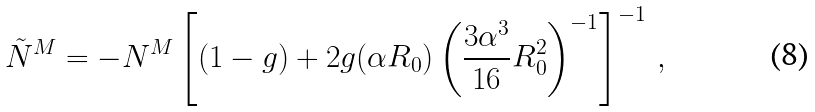Convert formula to latex. <formula><loc_0><loc_0><loc_500><loc_500>\tilde { N } ^ { M } = - N ^ { M } \left [ ( 1 - g ) + 2 g ( \alpha R _ { 0 } ) \left ( \frac { 3 \alpha ^ { 3 } } { 1 6 } R _ { 0 } ^ { 2 } \right ) ^ { - 1 } \right ] ^ { - 1 } \, ,</formula> 